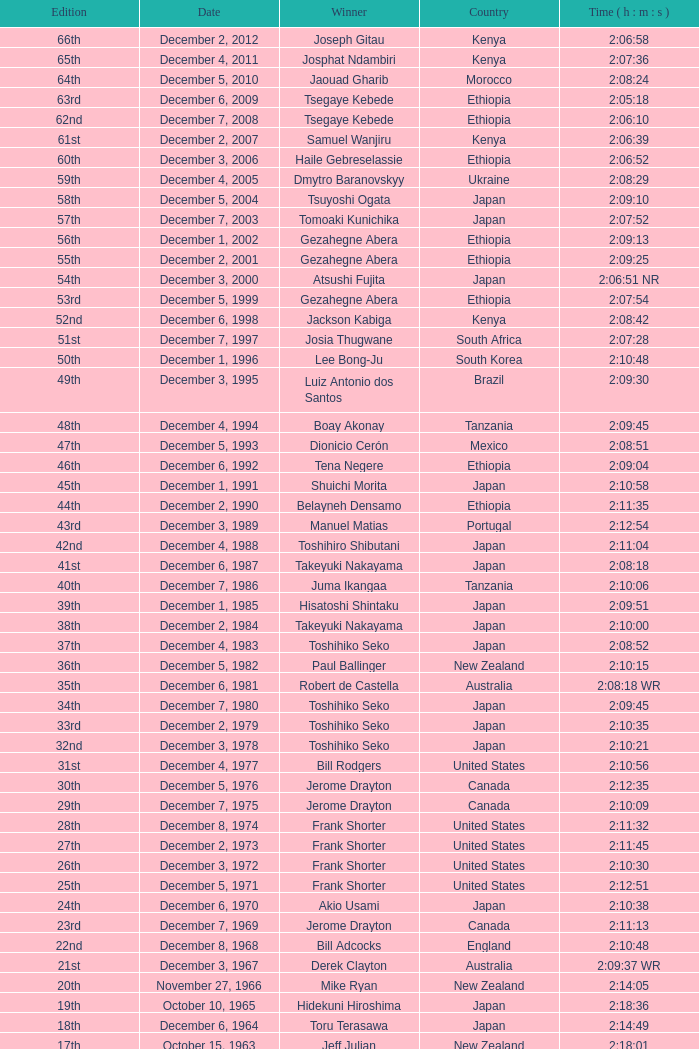What was the nationality of the winner of the 42nd Edition? Japan. Parse the table in full. {'header': ['Edition', 'Date', 'Winner', 'Country', 'Time ( h : m : s )'], 'rows': [['66th', 'December 2, 2012', 'Joseph Gitau', 'Kenya', '2:06:58'], ['65th', 'December 4, 2011', 'Josphat Ndambiri', 'Kenya', '2:07:36'], ['64th', 'December 5, 2010', 'Jaouad Gharib', 'Morocco', '2:08:24'], ['63rd', 'December 6, 2009', 'Tsegaye Kebede', 'Ethiopia', '2:05:18'], ['62nd', 'December 7, 2008', 'Tsegaye Kebede', 'Ethiopia', '2:06:10'], ['61st', 'December 2, 2007', 'Samuel Wanjiru', 'Kenya', '2:06:39'], ['60th', 'December 3, 2006', 'Haile Gebreselassie', 'Ethiopia', '2:06:52'], ['59th', 'December 4, 2005', 'Dmytro Baranovskyy', 'Ukraine', '2:08:29'], ['58th', 'December 5, 2004', 'Tsuyoshi Ogata', 'Japan', '2:09:10'], ['57th', 'December 7, 2003', 'Tomoaki Kunichika', 'Japan', '2:07:52'], ['56th', 'December 1, 2002', 'Gezahegne Abera', 'Ethiopia', '2:09:13'], ['55th', 'December 2, 2001', 'Gezahegne Abera', 'Ethiopia', '2:09:25'], ['54th', 'December 3, 2000', 'Atsushi Fujita', 'Japan', '2:06:51 NR'], ['53rd', 'December 5, 1999', 'Gezahegne Abera', 'Ethiopia', '2:07:54'], ['52nd', 'December 6, 1998', 'Jackson Kabiga', 'Kenya', '2:08:42'], ['51st', 'December 7, 1997', 'Josia Thugwane', 'South Africa', '2:07:28'], ['50th', 'December 1, 1996', 'Lee Bong-Ju', 'South Korea', '2:10:48'], ['49th', 'December 3, 1995', 'Luiz Antonio dos Santos', 'Brazil', '2:09:30'], ['48th', 'December 4, 1994', 'Boay Akonay', 'Tanzania', '2:09:45'], ['47th', 'December 5, 1993', 'Dionicio Cerón', 'Mexico', '2:08:51'], ['46th', 'December 6, 1992', 'Tena Negere', 'Ethiopia', '2:09:04'], ['45th', 'December 1, 1991', 'Shuichi Morita', 'Japan', '2:10:58'], ['44th', 'December 2, 1990', 'Belayneh Densamo', 'Ethiopia', '2:11:35'], ['43rd', 'December 3, 1989', 'Manuel Matias', 'Portugal', '2:12:54'], ['42nd', 'December 4, 1988', 'Toshihiro Shibutani', 'Japan', '2:11:04'], ['41st', 'December 6, 1987', 'Takeyuki Nakayama', 'Japan', '2:08:18'], ['40th', 'December 7, 1986', 'Juma Ikangaa', 'Tanzania', '2:10:06'], ['39th', 'December 1, 1985', 'Hisatoshi Shintaku', 'Japan', '2:09:51'], ['38th', 'December 2, 1984', 'Takeyuki Nakayama', 'Japan', '2:10:00'], ['37th', 'December 4, 1983', 'Toshihiko Seko', 'Japan', '2:08:52'], ['36th', 'December 5, 1982', 'Paul Ballinger', 'New Zealand', '2:10:15'], ['35th', 'December 6, 1981', 'Robert de Castella', 'Australia', '2:08:18 WR'], ['34th', 'December 7, 1980', 'Toshihiko Seko', 'Japan', '2:09:45'], ['33rd', 'December 2, 1979', 'Toshihiko Seko', 'Japan', '2:10:35'], ['32nd', 'December 3, 1978', 'Toshihiko Seko', 'Japan', '2:10:21'], ['31st', 'December 4, 1977', 'Bill Rodgers', 'United States', '2:10:56'], ['30th', 'December 5, 1976', 'Jerome Drayton', 'Canada', '2:12:35'], ['29th', 'December 7, 1975', 'Jerome Drayton', 'Canada', '2:10:09'], ['28th', 'December 8, 1974', 'Frank Shorter', 'United States', '2:11:32'], ['27th', 'December 2, 1973', 'Frank Shorter', 'United States', '2:11:45'], ['26th', 'December 3, 1972', 'Frank Shorter', 'United States', '2:10:30'], ['25th', 'December 5, 1971', 'Frank Shorter', 'United States', '2:12:51'], ['24th', 'December 6, 1970', 'Akio Usami', 'Japan', '2:10:38'], ['23rd', 'December 7, 1969', 'Jerome Drayton', 'Canada', '2:11:13'], ['22nd', 'December 8, 1968', 'Bill Adcocks', 'England', '2:10:48'], ['21st', 'December 3, 1967', 'Derek Clayton', 'Australia', '2:09:37 WR'], ['20th', 'November 27, 1966', 'Mike Ryan', 'New Zealand', '2:14:05'], ['19th', 'October 10, 1965', 'Hidekuni Hiroshima', 'Japan', '2:18:36'], ['18th', 'December 6, 1964', 'Toru Terasawa', 'Japan', '2:14:49'], ['17th', 'October 15, 1963', 'Jeff Julian', 'New Zealand', '2:18:01'], ['16th', 'December 2, 1962', 'Toru Terasawa', 'Japan', '2:16:19'], ['15th', 'December 3, 1961', 'Pavel Kantorek', 'Czech Republic', '2:22:05'], ['14th', 'December 4, 1960', 'Barry Magee', 'New Zealand', '2:19:04'], ['13th', 'November 8, 1959', 'Kurao Hiroshima', 'Japan', '2:29:34'], ['12th', 'December 7, 1958', 'Nobuyoshi Sadanaga', 'Japan', '2:24:01'], ['11th', 'December 1, 1957', 'Kurao Hiroshima', 'Japan', '2:21:40'], ['10th', 'December 9, 1956', 'Keizo Yamada', 'Japan', '2:25:15'], ['9th', 'December 11, 1955', 'Veikko Karvonen', 'Finland', '2:23:16'], ['8th', 'December 5, 1954', 'Reinaldo Gorno', 'Argentina', '2:24:55'], ['7th', 'December 6, 1953', 'Hideo Hamamura', 'Japan', '2:27:26'], ['6th', 'December 7, 1952', 'Katsuo Nishida', 'Japan', '2:27:59'], ['5th', 'December 9, 1951', 'Hiromi Haigo', 'Japan', '2:30:13'], ['4th', 'December 10, 1950', 'Shunji Koyanagi', 'Japan', '2:30:47'], ['3rd', 'December 4, 1949', 'Shinzo Koga', 'Japan', '2:40:26'], ['2nd', 'December 5, 1948', 'Saburo Yamada', 'Japan', '2:37:25'], ['1st', 'December 7, 1947', 'Toshikazu Wada', 'Japan', '2:45:45']]} 